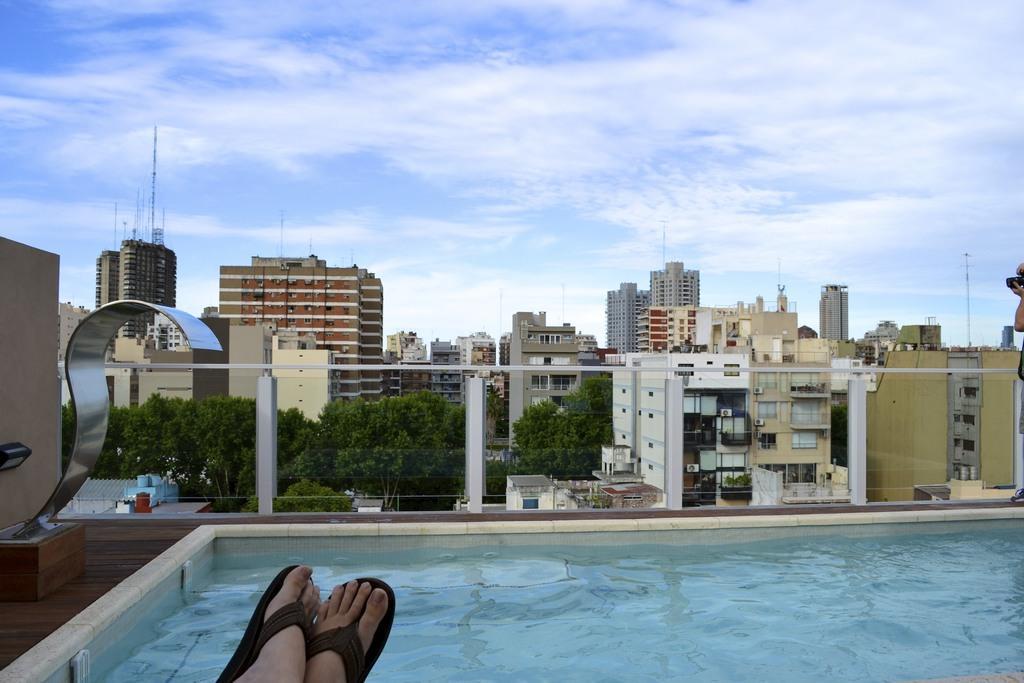Describe this image in one or two sentences. In the center of the image we can see the buildings, poles, trees, windows, roofs, railing. At the bottom of the image we can see a pool which contains water and also we can see a person's legs and footwear. On the left side of the image we can see the wall and structure. On the right side of the image we can see a person is standing and holding a camera. At the top of the image we can see the clouds are present in the sky. 